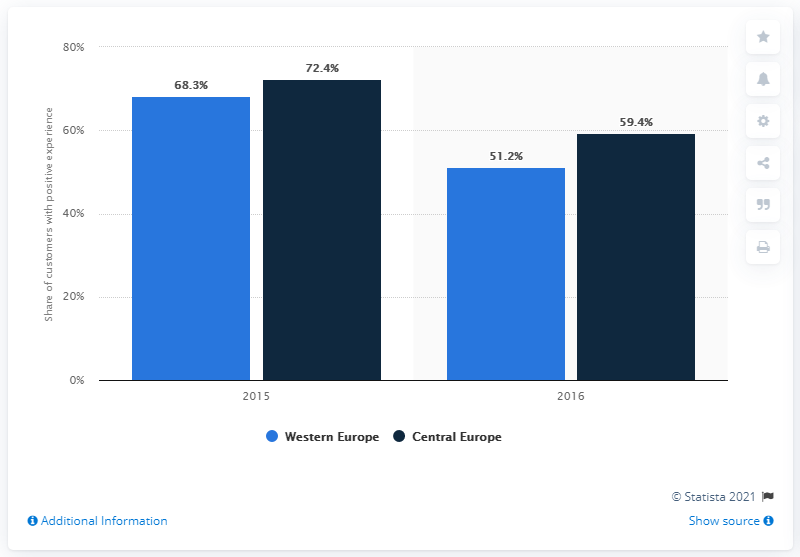List a handful of essential elements in this visual. According to a survey conducted in 2016, 59.4% of Generation Y customers in Central Europe reported being satisfied with their retail banking experience. According to the data, Millennials reported lower levels of satisfaction in 2016 than in the previous year. According to a survey conducted in 2016, 51.2% of Generation Y customers in Western and Central Europe were satisfied with their retail banking experience. 